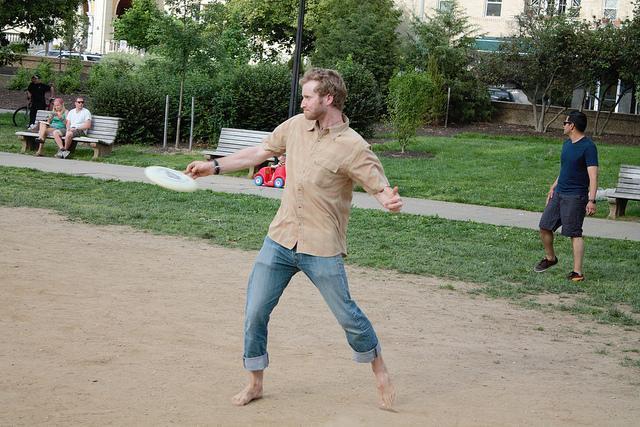How many people are wearing shorts?
Give a very brief answer. 3. How many people are there?
Give a very brief answer. 2. 